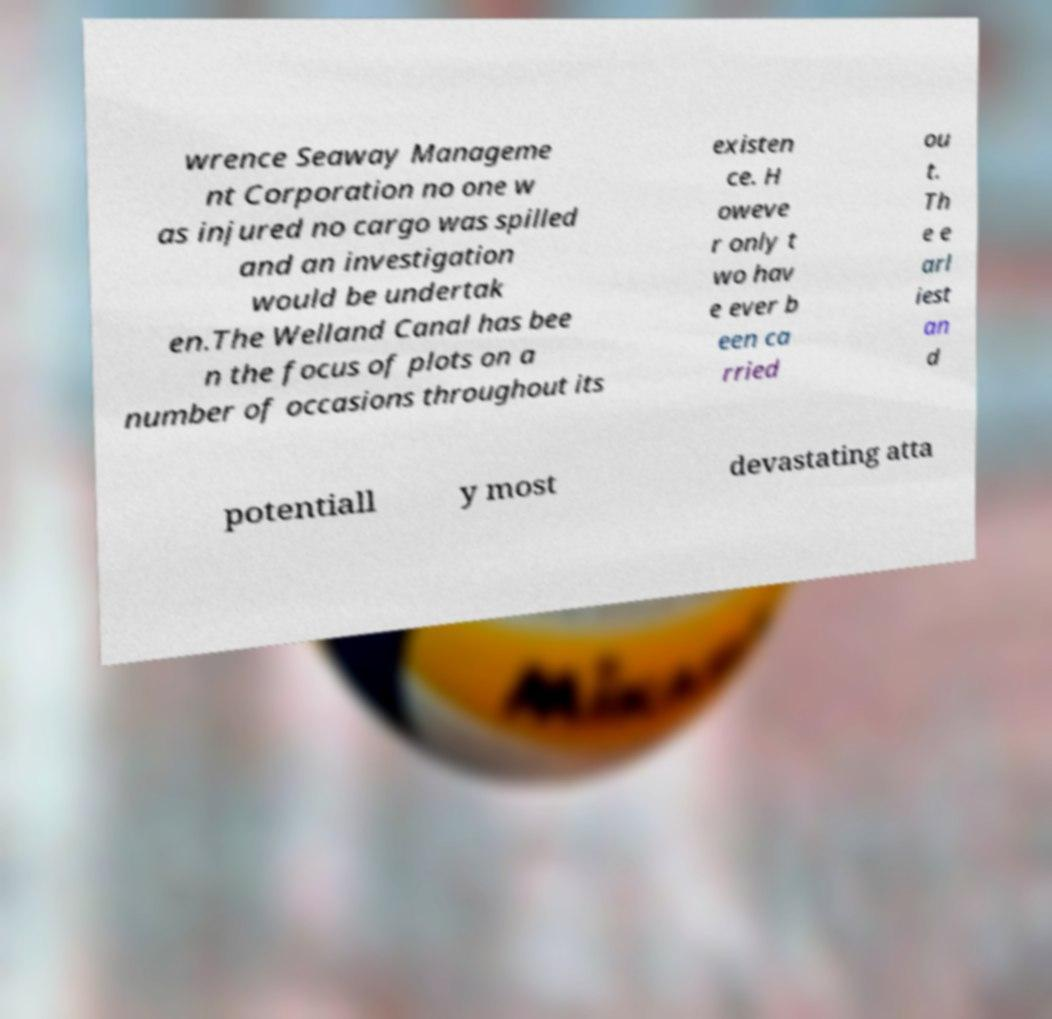Could you assist in decoding the text presented in this image and type it out clearly? wrence Seaway Manageme nt Corporation no one w as injured no cargo was spilled and an investigation would be undertak en.The Welland Canal has bee n the focus of plots on a number of occasions throughout its existen ce. H oweve r only t wo hav e ever b een ca rried ou t. Th e e arl iest an d potentiall y most devastating atta 